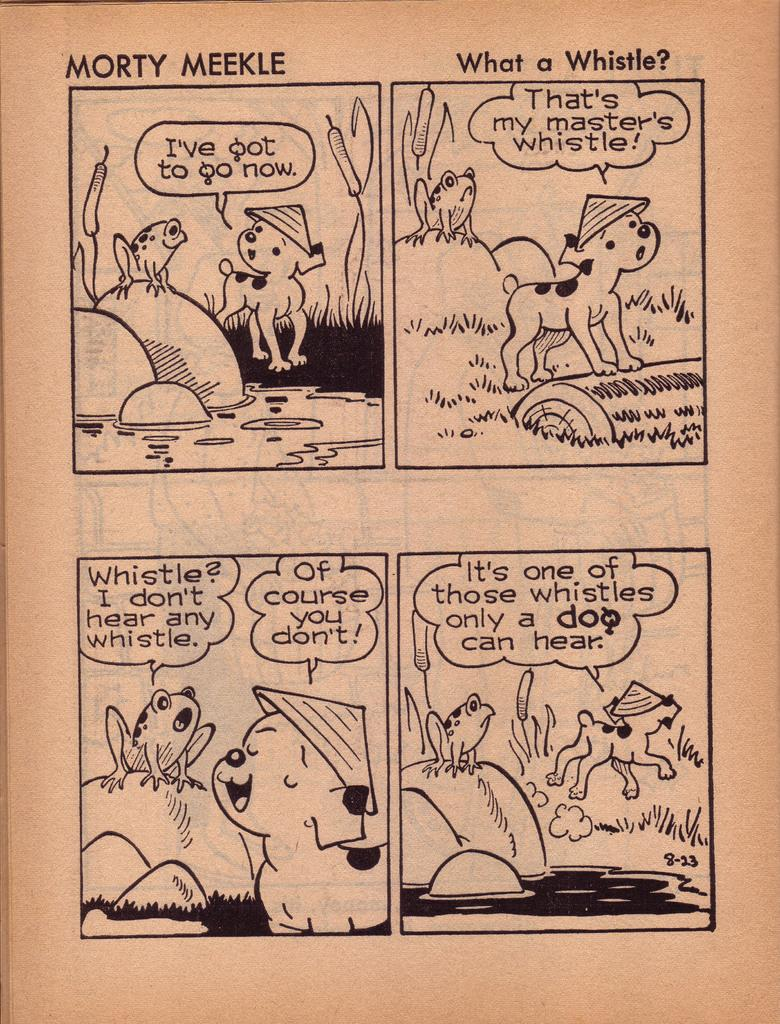Provide a one-sentence caption for the provided image. a Morty Meekle comic strip that appears to be very vintage. 